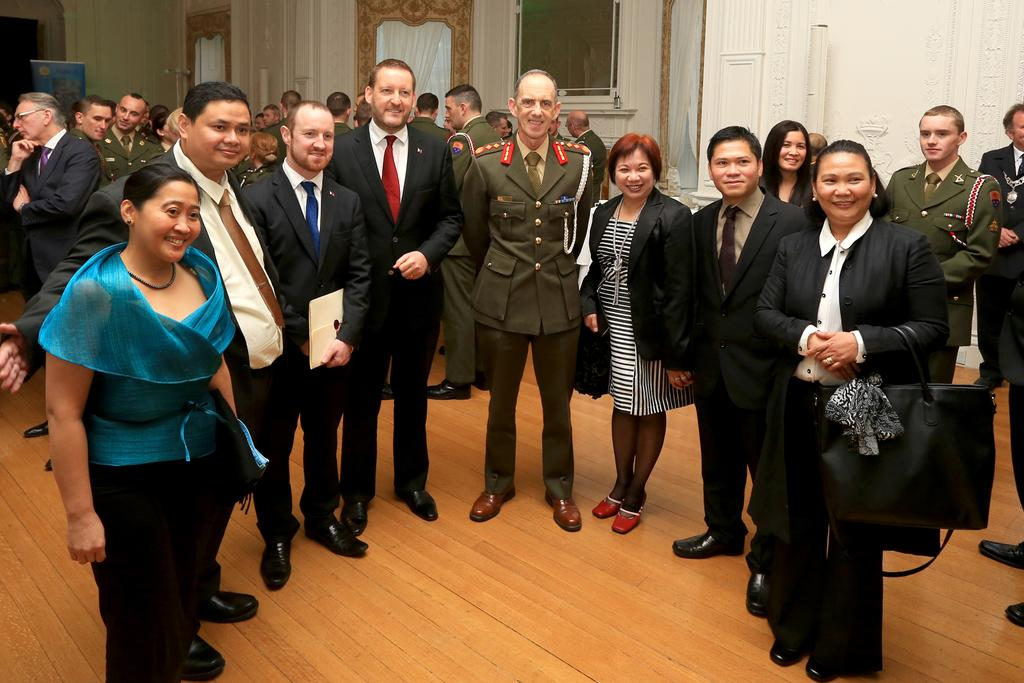Who or what is present in the image? There are people in the image. What type of objects can be seen in the image? There are wooden objects in the image. What architectural features are visible in the image? There are walls in the image. What surface is visible beneath the people and objects? There is a floor in the image. What type of crayon can be seen melting on the floor in the image? There is no crayon present in the image, and therefore no such activity can be observed. 